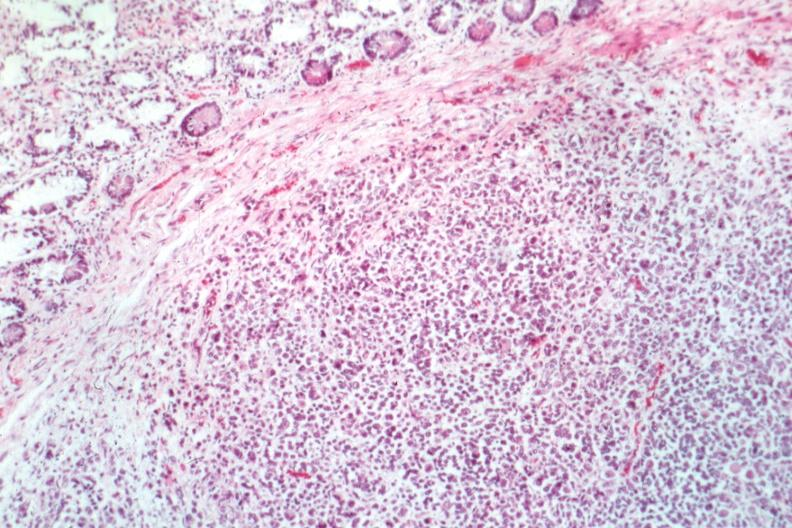does this image show good example can tell even at this what the tumor is?
Answer the question using a single word or phrase. Yes 